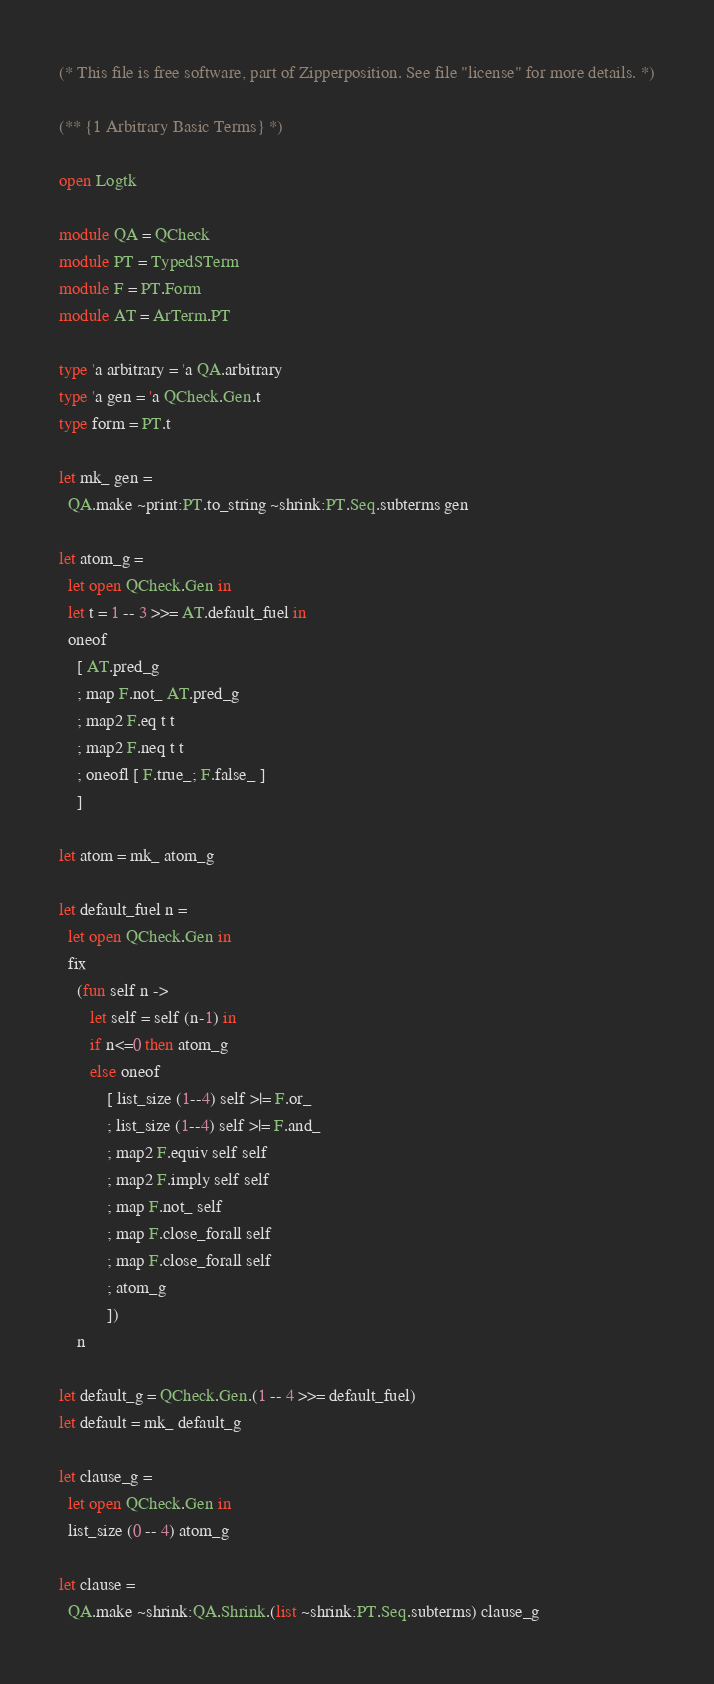<code> <loc_0><loc_0><loc_500><loc_500><_OCaml_>
(* This file is free software, part of Zipperposition. See file "license" for more details. *)

(** {1 Arbitrary Basic Terms} *)

open Logtk

module QA = QCheck
module PT = TypedSTerm
module F = PT.Form
module AT = ArTerm.PT

type 'a arbitrary = 'a QA.arbitrary
type 'a gen = 'a QCheck.Gen.t
type form = PT.t

let mk_ gen =
  QA.make ~print:PT.to_string ~shrink:PT.Seq.subterms gen

let atom_g =
  let open QCheck.Gen in
  let t = 1 -- 3 >>= AT.default_fuel in
  oneof
    [ AT.pred_g
    ; map F.not_ AT.pred_g
    ; map2 F.eq t t
    ; map2 F.neq t t
    ; oneofl [ F.true_; F.false_ ]
    ]

let atom = mk_ atom_g

let default_fuel n =
  let open QCheck.Gen in
  fix
    (fun self n ->
       let self = self (n-1) in
       if n<=0 then atom_g
       else oneof
           [ list_size (1--4) self >|= F.or_
           ; list_size (1--4) self >|= F.and_
           ; map2 F.equiv self self
           ; map2 F.imply self self
           ; map F.not_ self
           ; map F.close_forall self
           ; map F.close_forall self
           ; atom_g
           ])
    n

let default_g = QCheck.Gen.(1 -- 4 >>= default_fuel)
let default = mk_ default_g

let clause_g =
  let open QCheck.Gen in
  list_size (0 -- 4) atom_g

let clause =
  QA.make ~shrink:QA.Shrink.(list ~shrink:PT.Seq.subterms) clause_g
</code> 